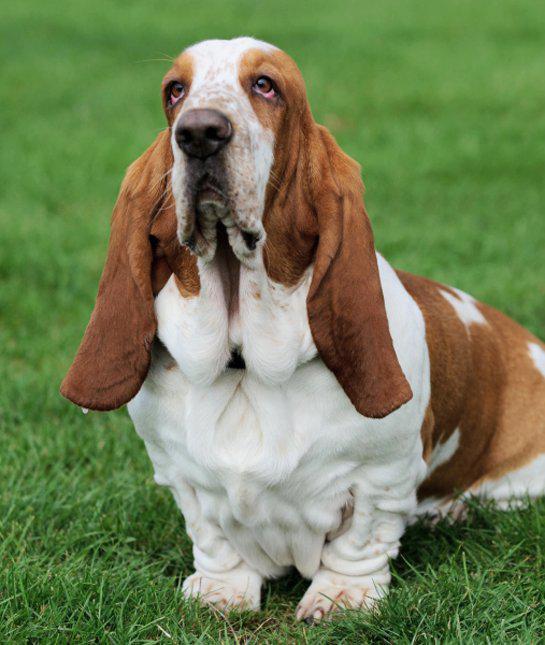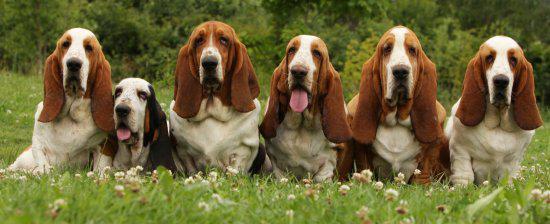The first image is the image on the left, the second image is the image on the right. Evaluate the accuracy of this statement regarding the images: "There are two dogs". Is it true? Answer yes or no. No. 